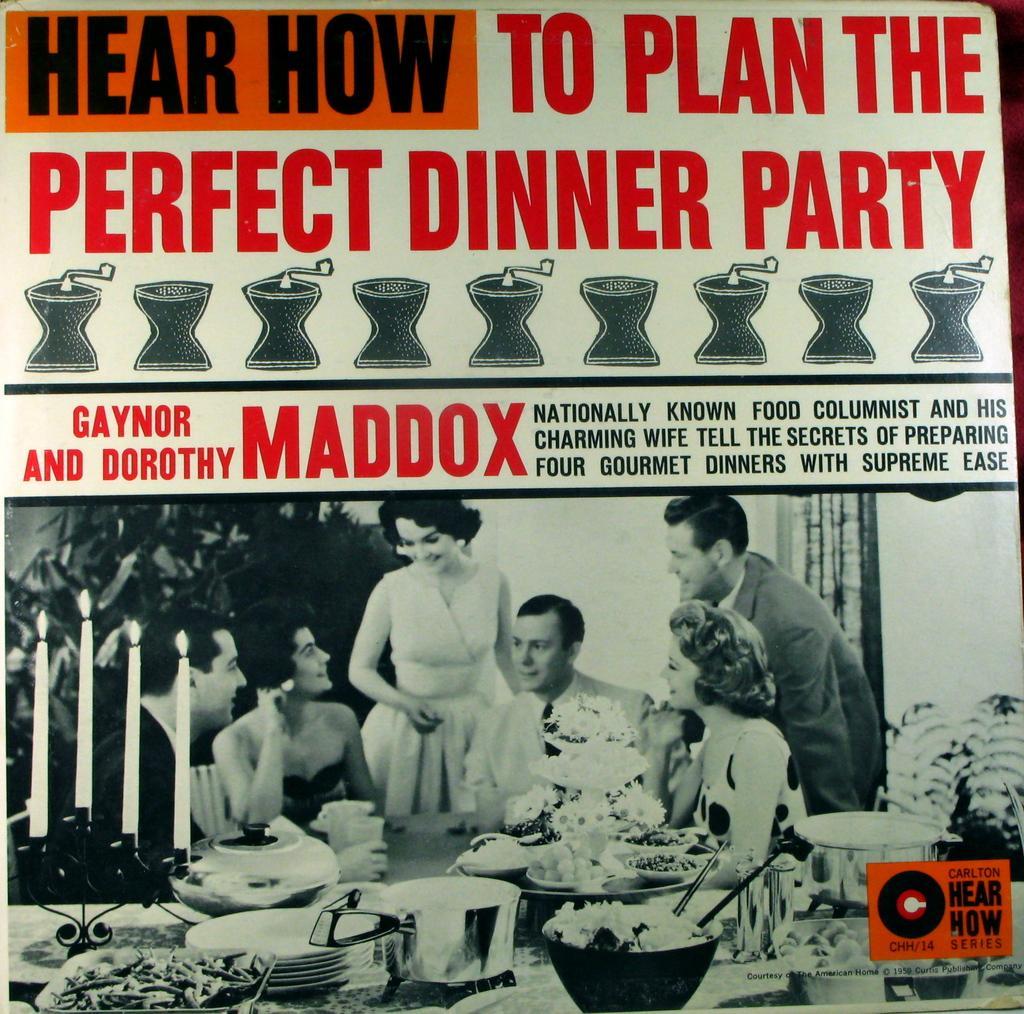Could you give a brief overview of what you see in this image? In this image we can see a poster. There is text. At the bottom of the image there are depictions of persons and other objects. 